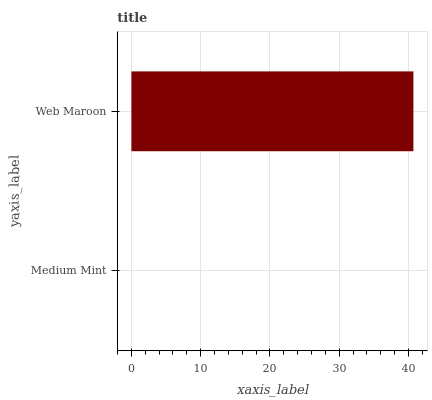Is Medium Mint the minimum?
Answer yes or no. Yes. Is Web Maroon the maximum?
Answer yes or no. Yes. Is Web Maroon the minimum?
Answer yes or no. No. Is Web Maroon greater than Medium Mint?
Answer yes or no. Yes. Is Medium Mint less than Web Maroon?
Answer yes or no. Yes. Is Medium Mint greater than Web Maroon?
Answer yes or no. No. Is Web Maroon less than Medium Mint?
Answer yes or no. No. Is Web Maroon the high median?
Answer yes or no. Yes. Is Medium Mint the low median?
Answer yes or no. Yes. Is Medium Mint the high median?
Answer yes or no. No. Is Web Maroon the low median?
Answer yes or no. No. 